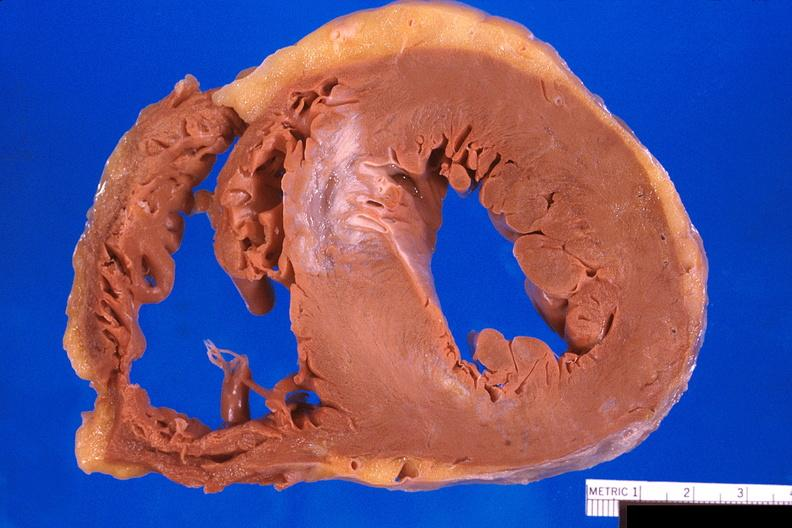how does this image show heart, old myocardial infarction?
Answer the question using a single word or phrase. With fibrosis 